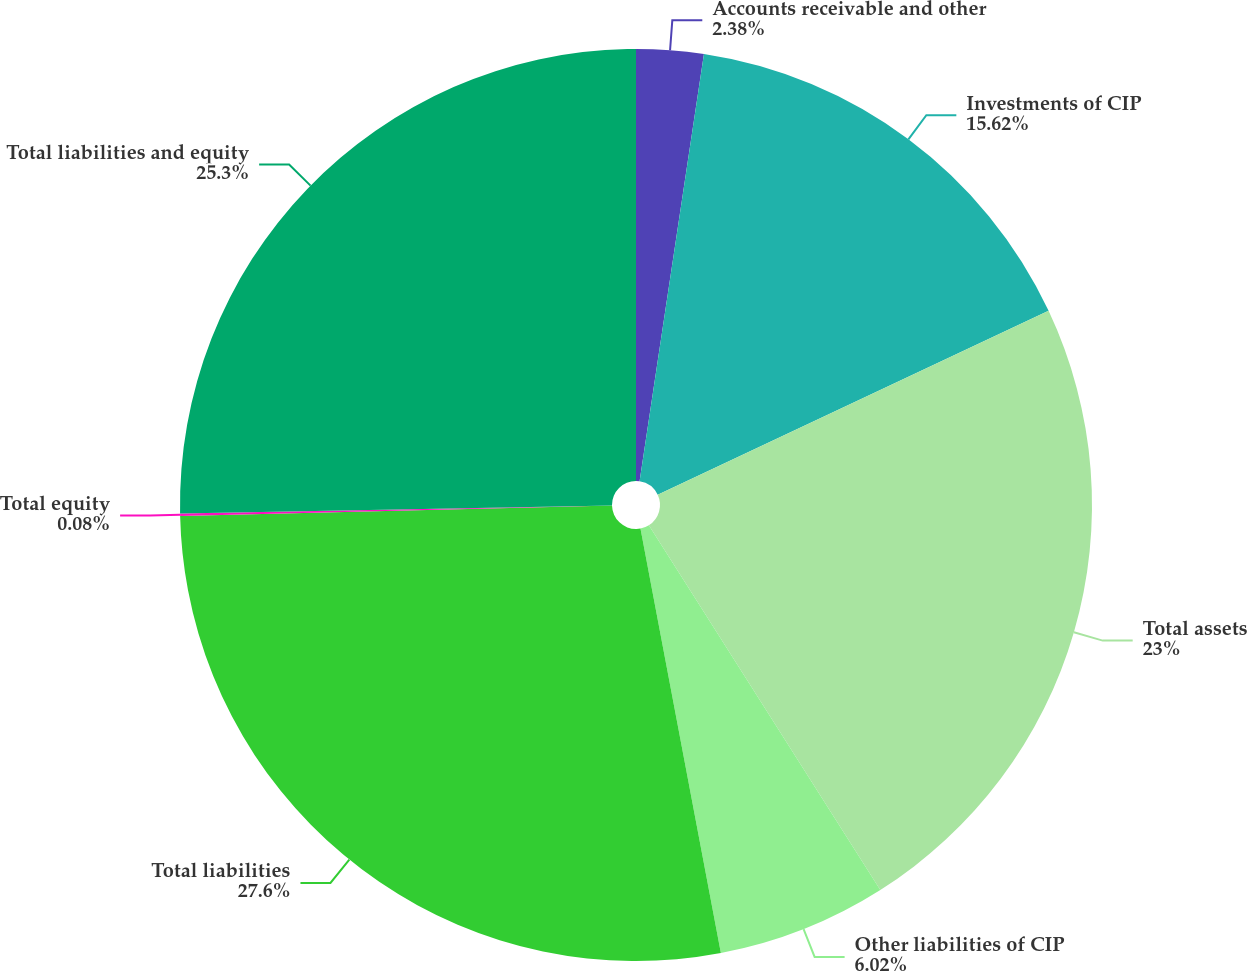<chart> <loc_0><loc_0><loc_500><loc_500><pie_chart><fcel>Accounts receivable and other<fcel>Investments of CIP<fcel>Total assets<fcel>Other liabilities of CIP<fcel>Total liabilities<fcel>Total equity<fcel>Total liabilities and equity<nl><fcel>2.38%<fcel>15.62%<fcel>23.0%<fcel>6.02%<fcel>27.6%<fcel>0.08%<fcel>25.3%<nl></chart> 